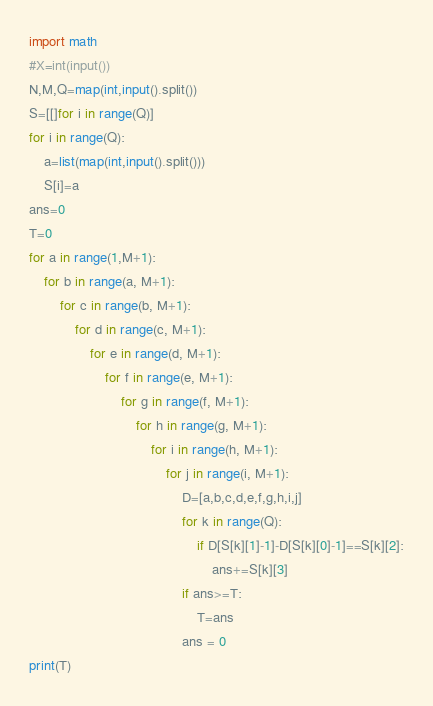<code> <loc_0><loc_0><loc_500><loc_500><_Python_>import math
#X=int(input())
N,M,Q=map(int,input().split())
S=[[]for i in range(Q)]
for i in range(Q):
    a=list(map(int,input().split()))
    S[i]=a
ans=0
T=0
for a in range(1,M+1):
    for b in range(a, M+1):
        for c in range(b, M+1):
            for d in range(c, M+1):
                for e in range(d, M+1):
                    for f in range(e, M+1):
                        for g in range(f, M+1):
                            for h in range(g, M+1):
                                for i in range(h, M+1):
                                    for j in range(i, M+1):
                                        D=[a,b,c,d,e,f,g,h,i,j]
                                        for k in range(Q):
                                            if D[S[k][1]-1]-D[S[k][0]-1]==S[k][2]:
                                                ans+=S[k][3]
                                        if ans>=T:
                                            T=ans
                                        ans = 0
print(T)
</code> 